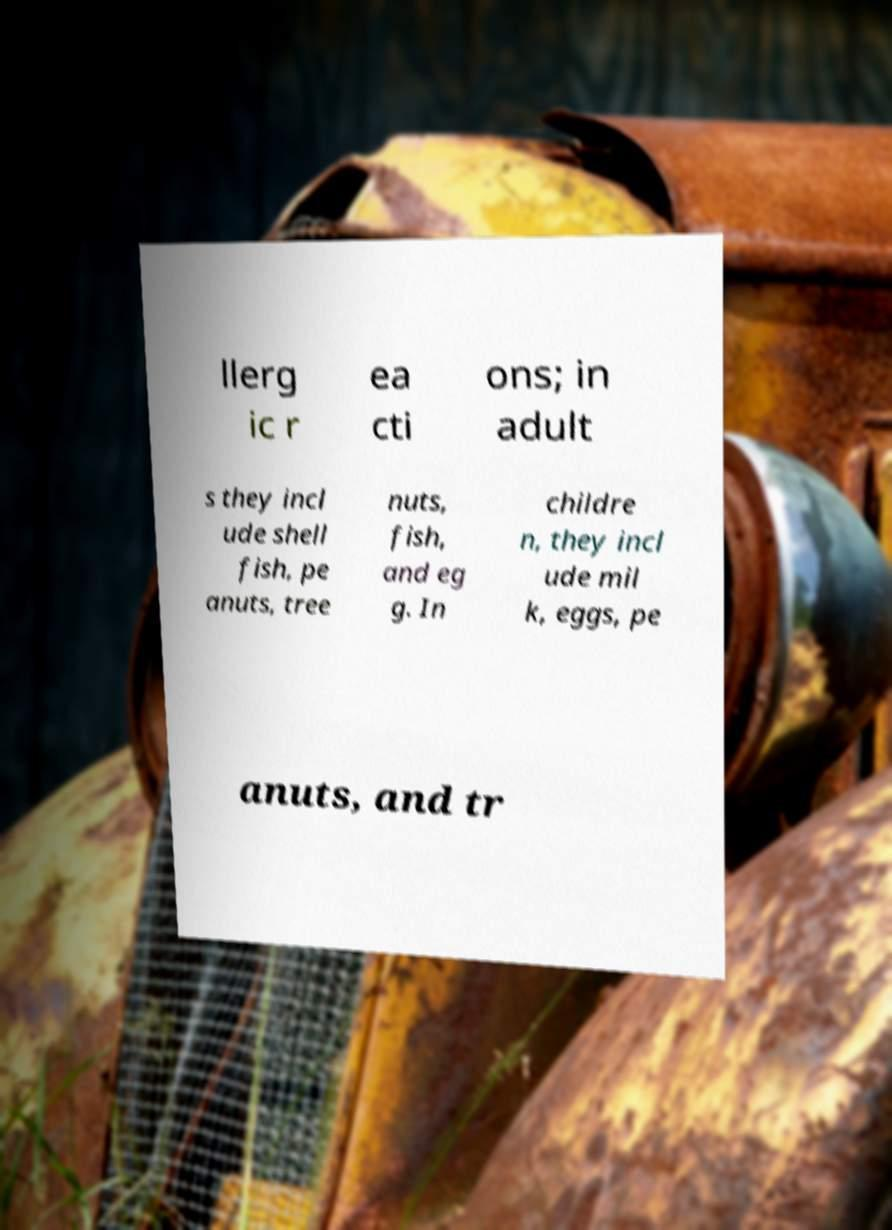I need the written content from this picture converted into text. Can you do that? llerg ic r ea cti ons; in adult s they incl ude shell fish, pe anuts, tree nuts, fish, and eg g. In childre n, they incl ude mil k, eggs, pe anuts, and tr 